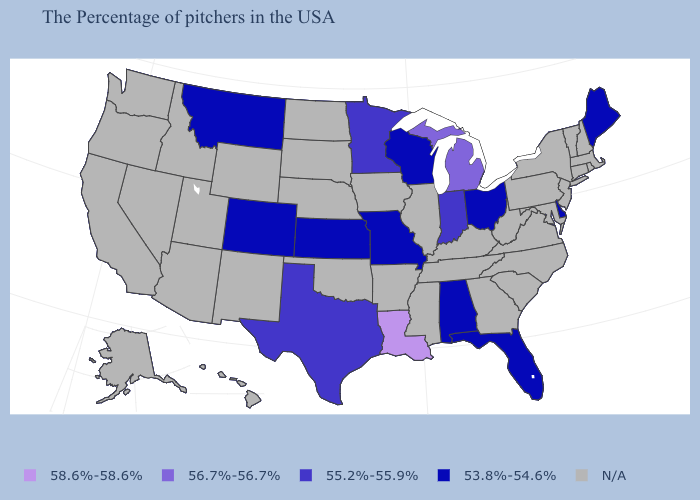What is the value of Vermont?
Short answer required. N/A. Does Texas have the lowest value in the USA?
Be succinct. No. What is the value of New Mexico?
Short answer required. N/A. Name the states that have a value in the range 55.2%-55.9%?
Answer briefly. Indiana, Minnesota, Texas. Name the states that have a value in the range 58.6%-58.6%?
Quick response, please. Louisiana. Which states hav the highest value in the Northeast?
Write a very short answer. Maine. Name the states that have a value in the range N/A?
Keep it brief. Massachusetts, Rhode Island, New Hampshire, Vermont, Connecticut, New York, New Jersey, Maryland, Pennsylvania, Virginia, North Carolina, South Carolina, West Virginia, Georgia, Kentucky, Tennessee, Illinois, Mississippi, Arkansas, Iowa, Nebraska, Oklahoma, South Dakota, North Dakota, Wyoming, New Mexico, Utah, Arizona, Idaho, Nevada, California, Washington, Oregon, Alaska, Hawaii. Name the states that have a value in the range 53.8%-54.6%?
Short answer required. Maine, Delaware, Ohio, Florida, Alabama, Wisconsin, Missouri, Kansas, Colorado, Montana. What is the lowest value in the MidWest?
Short answer required. 53.8%-54.6%. Name the states that have a value in the range 58.6%-58.6%?
Answer briefly. Louisiana. Which states have the highest value in the USA?
Concise answer only. Louisiana. Does the first symbol in the legend represent the smallest category?
Be succinct. No. 